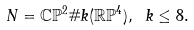Convert formula to latex. <formula><loc_0><loc_0><loc_500><loc_500>N = \mathbb { C P } ^ { 2 } \# k ( \mathbb { R P } ^ { 4 } ) , \ k \leq 8 .</formula> 